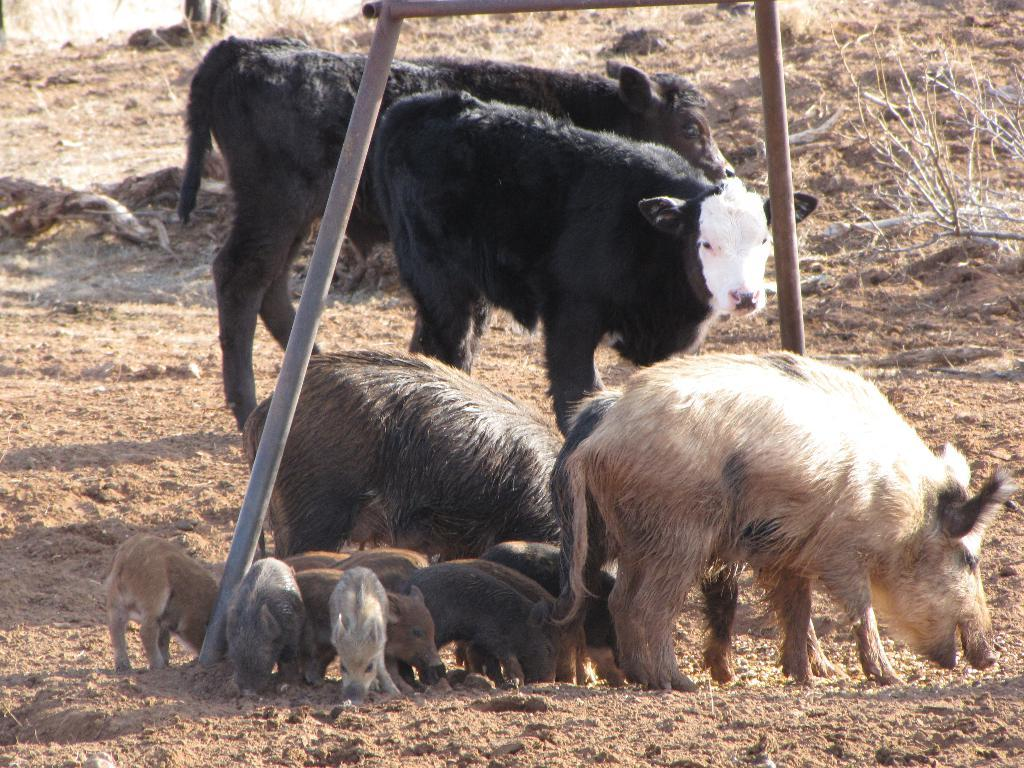What type of animals can be seen on the ground in the image? There are animals on the ground in the image, but their specific type is not mentioned in the facts. What structure is present in the image? There is a stand in the image. What natural elements can be seen in the image? There are twigs visible in the image. What is the animals' desire in the image? There is no information about the animals' desires in the image. Who is the animals' crush in the image? There is no information about any crushes in the image. 